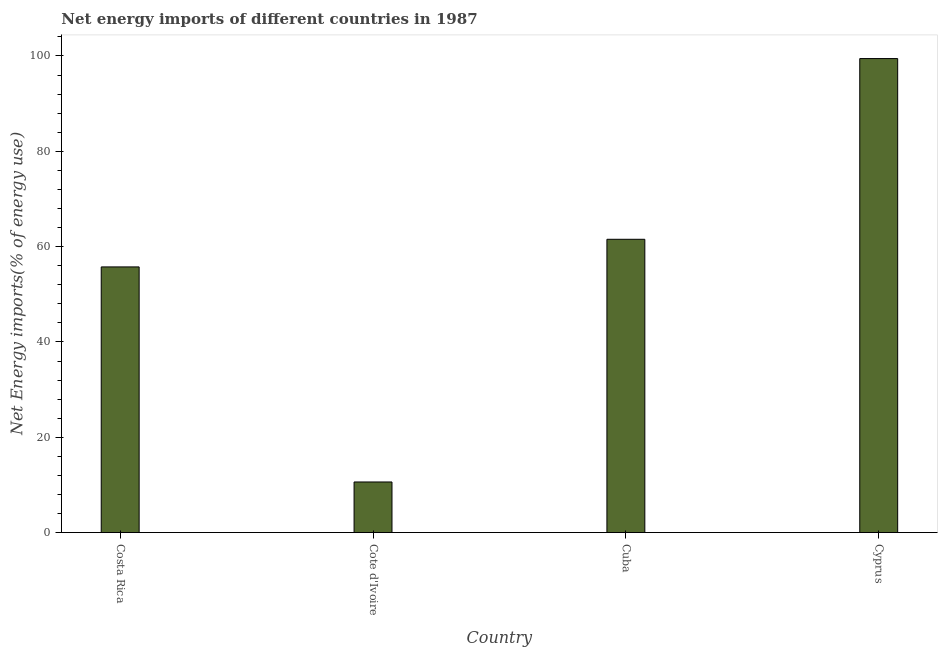Does the graph contain any zero values?
Your response must be concise. No. What is the title of the graph?
Ensure brevity in your answer.  Net energy imports of different countries in 1987. What is the label or title of the Y-axis?
Provide a short and direct response. Net Energy imports(% of energy use). What is the energy imports in Cuba?
Offer a very short reply. 61.54. Across all countries, what is the maximum energy imports?
Your answer should be compact. 99.45. Across all countries, what is the minimum energy imports?
Your answer should be very brief. 10.62. In which country was the energy imports maximum?
Your response must be concise. Cyprus. In which country was the energy imports minimum?
Ensure brevity in your answer.  Cote d'Ivoire. What is the sum of the energy imports?
Provide a short and direct response. 227.35. What is the difference between the energy imports in Costa Rica and Cyprus?
Provide a short and direct response. -43.71. What is the average energy imports per country?
Offer a terse response. 56.84. What is the median energy imports?
Your answer should be very brief. 58.64. What is the ratio of the energy imports in Cote d'Ivoire to that in Cyprus?
Keep it short and to the point. 0.11. Is the energy imports in Costa Rica less than that in Cuba?
Keep it short and to the point. Yes. Is the difference between the energy imports in Cote d'Ivoire and Cyprus greater than the difference between any two countries?
Provide a short and direct response. Yes. What is the difference between the highest and the second highest energy imports?
Make the answer very short. 37.91. What is the difference between the highest and the lowest energy imports?
Offer a very short reply. 88.83. In how many countries, is the energy imports greater than the average energy imports taken over all countries?
Keep it short and to the point. 2. How many bars are there?
Your answer should be compact. 4. Are all the bars in the graph horizontal?
Offer a very short reply. No. How many countries are there in the graph?
Offer a terse response. 4. What is the difference between two consecutive major ticks on the Y-axis?
Make the answer very short. 20. Are the values on the major ticks of Y-axis written in scientific E-notation?
Keep it short and to the point. No. What is the Net Energy imports(% of energy use) in Costa Rica?
Give a very brief answer. 55.74. What is the Net Energy imports(% of energy use) in Cote d'Ivoire?
Your answer should be compact. 10.62. What is the Net Energy imports(% of energy use) of Cuba?
Your answer should be compact. 61.54. What is the Net Energy imports(% of energy use) in Cyprus?
Your answer should be compact. 99.45. What is the difference between the Net Energy imports(% of energy use) in Costa Rica and Cote d'Ivoire?
Give a very brief answer. 45.12. What is the difference between the Net Energy imports(% of energy use) in Costa Rica and Cuba?
Offer a very short reply. -5.8. What is the difference between the Net Energy imports(% of energy use) in Costa Rica and Cyprus?
Your answer should be compact. -43.71. What is the difference between the Net Energy imports(% of energy use) in Cote d'Ivoire and Cuba?
Your response must be concise. -50.92. What is the difference between the Net Energy imports(% of energy use) in Cote d'Ivoire and Cyprus?
Ensure brevity in your answer.  -88.83. What is the difference between the Net Energy imports(% of energy use) in Cuba and Cyprus?
Keep it short and to the point. -37.91. What is the ratio of the Net Energy imports(% of energy use) in Costa Rica to that in Cote d'Ivoire?
Give a very brief answer. 5.25. What is the ratio of the Net Energy imports(% of energy use) in Costa Rica to that in Cuba?
Ensure brevity in your answer.  0.91. What is the ratio of the Net Energy imports(% of energy use) in Costa Rica to that in Cyprus?
Provide a short and direct response. 0.56. What is the ratio of the Net Energy imports(% of energy use) in Cote d'Ivoire to that in Cuba?
Your response must be concise. 0.17. What is the ratio of the Net Energy imports(% of energy use) in Cote d'Ivoire to that in Cyprus?
Provide a short and direct response. 0.11. What is the ratio of the Net Energy imports(% of energy use) in Cuba to that in Cyprus?
Your answer should be very brief. 0.62. 